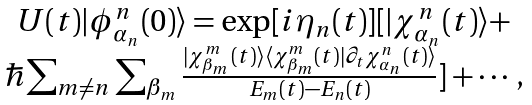<formula> <loc_0><loc_0><loc_500><loc_500>\begin{array} { c } U ( t ) | \phi ^ { n } _ { \alpha _ { n } } ( 0 ) \rangle = \exp [ i \eta _ { n } ( t ) ] [ | \chi ^ { n } _ { \alpha _ { n } } ( t ) \rangle + \\ \hbar { \sum } _ { m \neq n } \sum _ { \beta _ { m } } \frac { | \chi ^ { m } _ { \beta _ { m } } ( t ) \rangle \langle \chi ^ { m } _ { \beta _ { m } } ( t ) | \partial _ { t } \chi ^ { n } _ { \alpha _ { n } } ( t ) \rangle } { E _ { m } ( t ) - E _ { n } ( t ) } ] + \cdots , \end{array}</formula> 